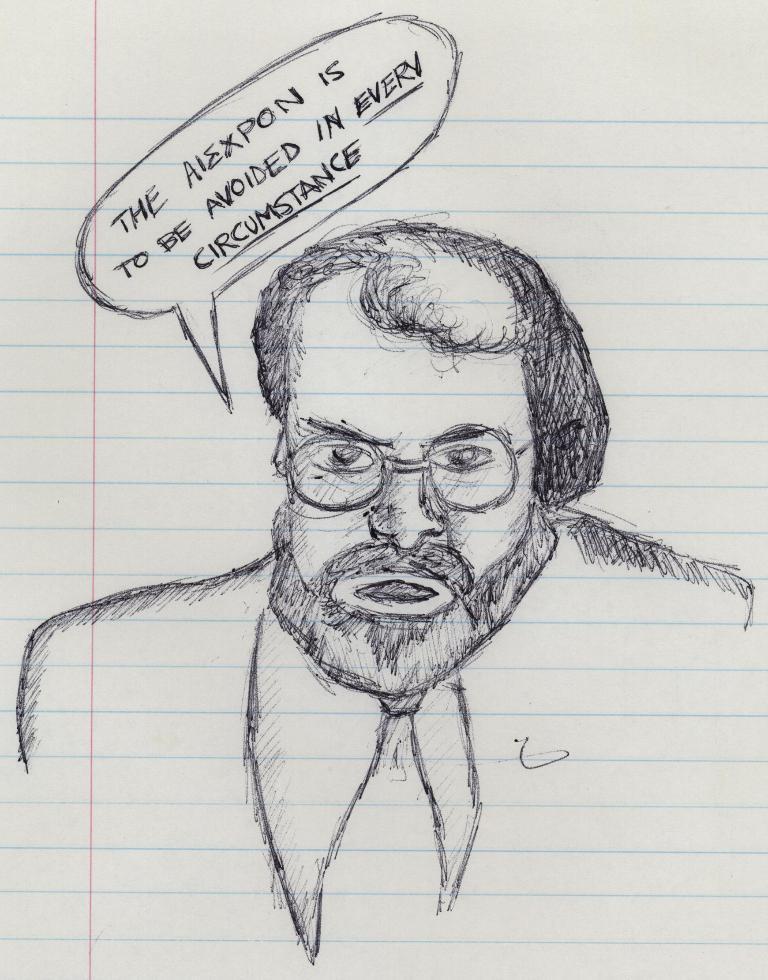Can you describe this image briefly? There is a drawing picture of a person on the paper in the middle of this image, and there is some text written at the top of this image. 